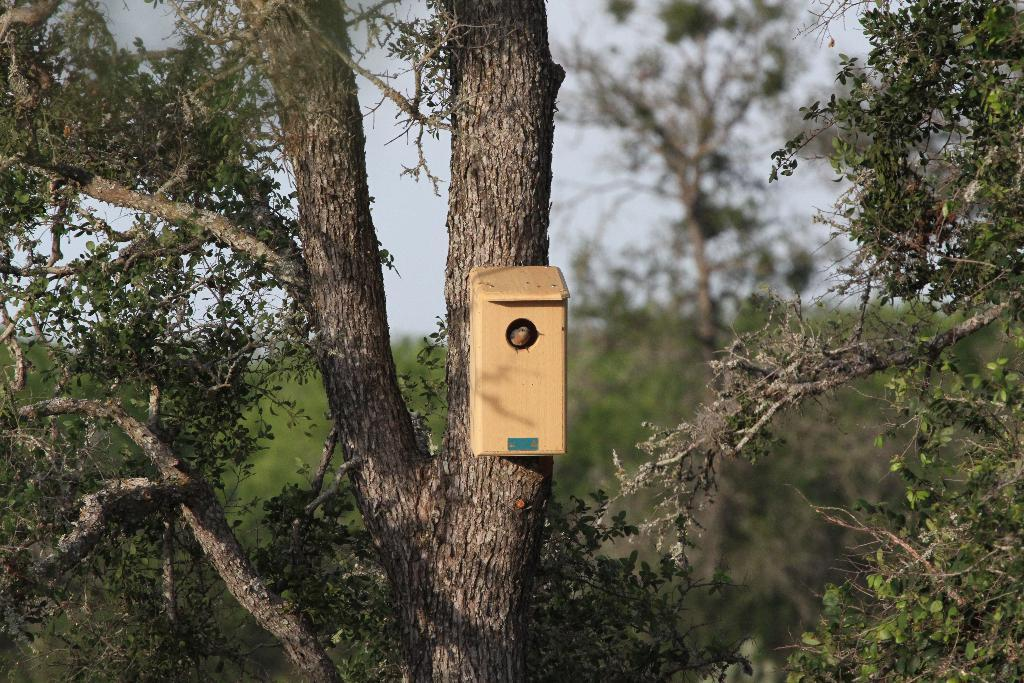What is present in the image? There is a tree in the image. Is there anything attached to the tree trunk? Yes, there is a box attached to the tree trunk. What can be found inside the box? A bird is inside the box. How many legs does the parcel have in the image? There is no parcel present in the image, so it is not possible to determine how many legs it might have. 